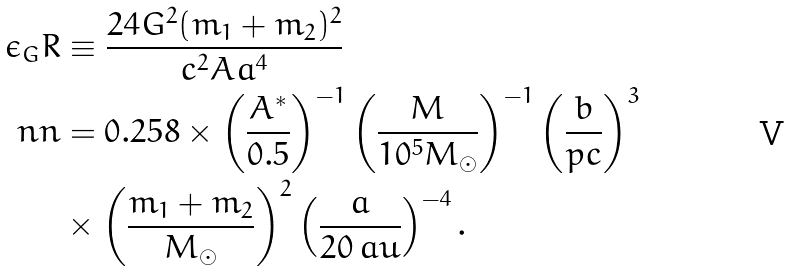Convert formula to latex. <formula><loc_0><loc_0><loc_500><loc_500>\epsilon _ { G } R & \equiv \frac { 2 4 G ^ { 2 } ( m _ { 1 } + m _ { 2 } ) ^ { 2 } } { c ^ { 2 } A a ^ { 4 } } \\ \ n n & = 0 . 2 5 8 \times \left ( \frac { A ^ { * } } { 0 . 5 } \right ) ^ { - 1 } \left ( \frac { M } { 1 0 ^ { 5 } M _ { \odot } } \right ) ^ { - 1 } \left ( \frac { b } { p c } \right ) ^ { 3 } \\ & \times \left ( \frac { m _ { 1 } + m _ { 2 } } { M _ { \odot } } \right ) ^ { 2 } \left ( \frac { a } { 2 0 \, a u } \right ) ^ { - 4 } .</formula> 